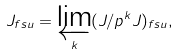<formula> <loc_0><loc_0><loc_500><loc_500>J _ { f s u } = \varprojlim _ { k } ( J / p ^ { k } J ) _ { f s u } ,</formula> 